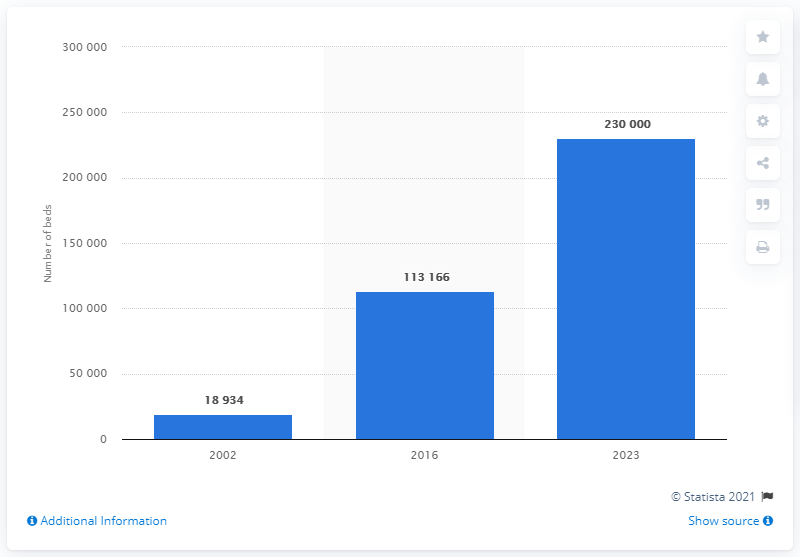Outline some significant characteristics in this image. According to Turkey's target, the hospital bed capacity of quality rooms is expected to be achieved by the year 2023. 